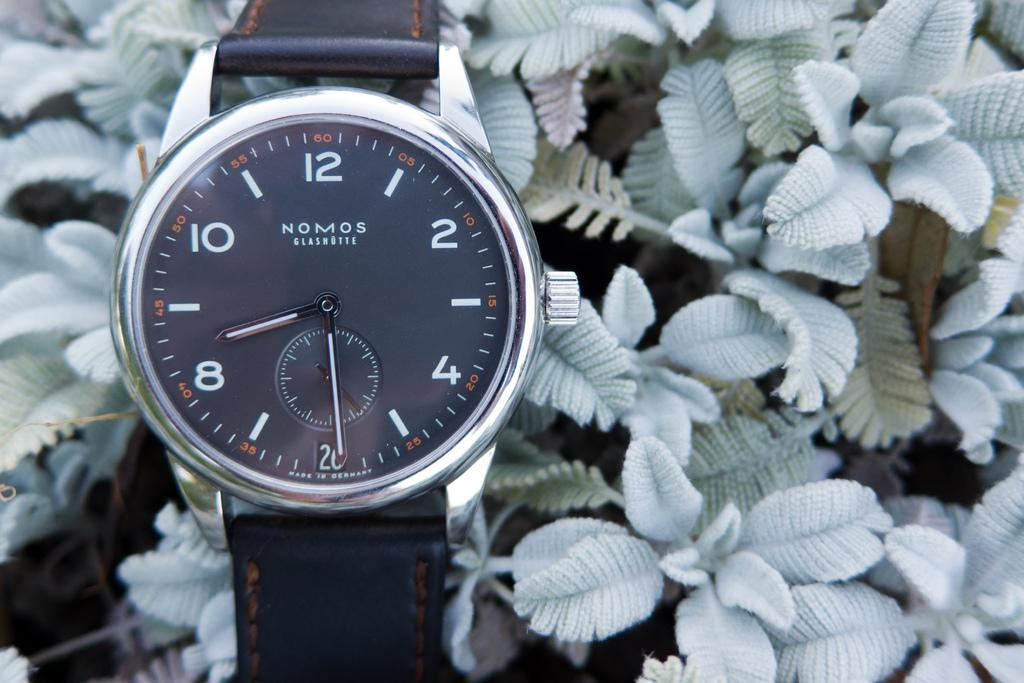<image>
Describe the image concisely. a NOMOS Glashutte wrist watch displayed amongst leafy plants 